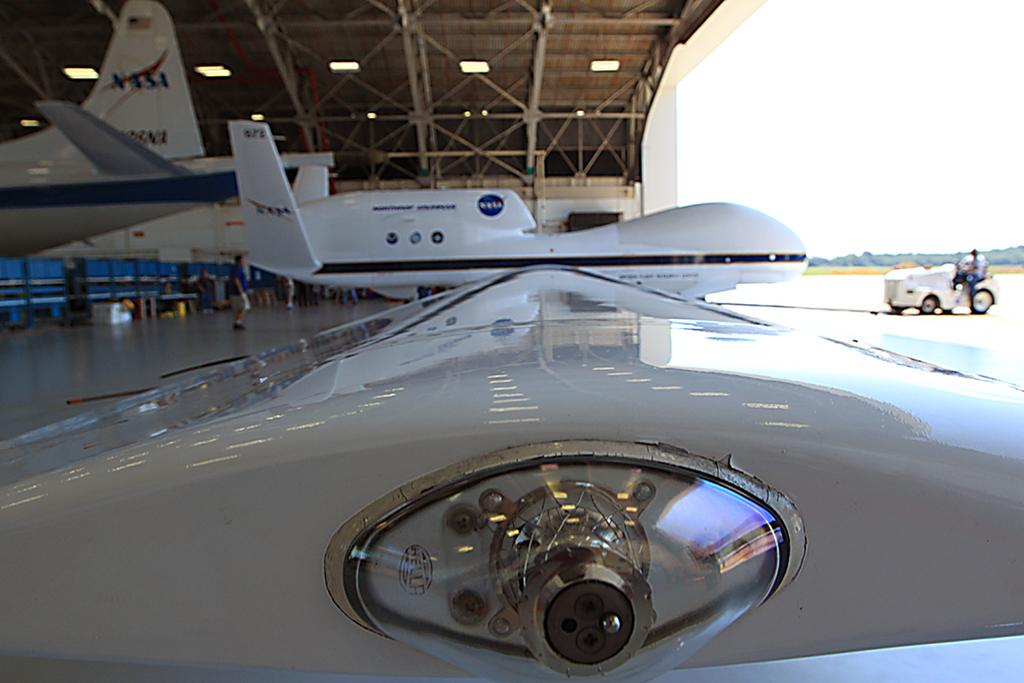<image>
Provide a brief description of the given image. A close up of a part of some aircraft in a hangar with planes from NASA in the background. 